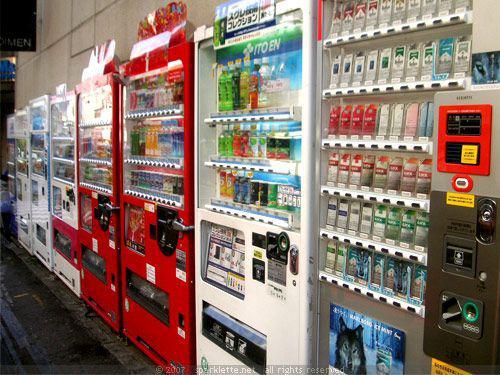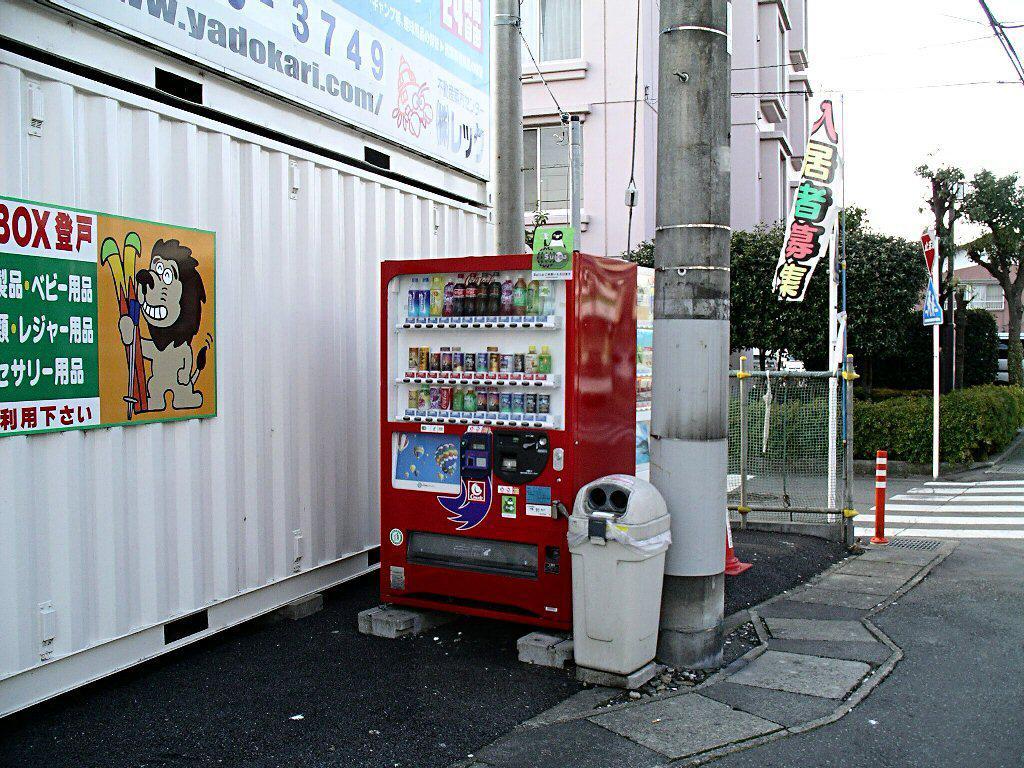The first image is the image on the left, the second image is the image on the right. For the images shown, is this caption "In the right image, there is no less than one person standing in front of and staring ahead at a row of vending machines" true? Answer yes or no. No. The first image is the image on the left, the second image is the image on the right. For the images shown, is this caption "At least one person is near the machines in the image on the right." true? Answer yes or no. No. 